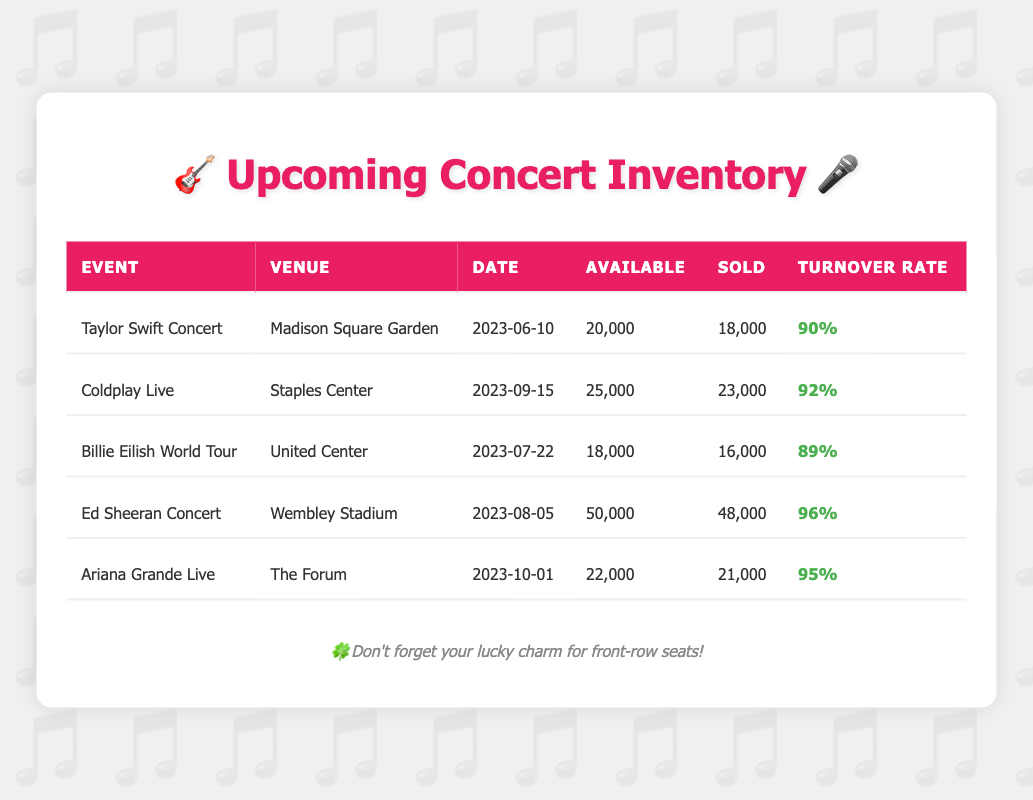What is the inventory turnover rate for the Ed Sheeran Concert? The table states that the inventory turnover rate for the Ed Sheeran Concert is displayed in the corresponding column, where it reads 96%.
Answer: 96% Which event had the highest number of tickets sold? By examining the 'Sold' column, the maximum value is 48,000 for the Ed Sheeran Concert, indicating it had the highest number of tickets sold.
Answer: Ed Sheeran Concert Is the inventory turnover rate for the Coldplay Live concert higher than 90%? The inventory turnover rate for Coldplay Live is 92%, which is indeed higher than 90%, confirming the statement is true.
Answer: Yes What is the total number of tickets sold across all events? Summing the tickets sold from each event gives 18,000 + 23,000 + 16,000 + 48,000 + 21,000 = 126,000. Therefore, the total number of tickets sold is 126,000.
Answer: 126,000 Which event had the lowest inventory turnover rate, and what was that rate? Looking at the inventory turnover rate column, the Billie Eilish World Tour shows the lowest rate at 89%, which can be confirmed by comparing all rates listed.
Answer: Billie Eilish World Tour, 89% Are there more concerts held in September than in June? The table shows one concert in June (Taylor Swift) and one in September (Coldplay Live), indicating there are not more in September.
Answer: No What is the average inventory turnover rate for all the concerts in the table? To find the average, add all turnover rates: (0.9 + 0.92 + 0.89 + 0.96 + 0.95) = 4.62. Divide by 5 (the number of events) to find the average: 4.62 / 5 = 0.924, or 92.4%.
Answer: 92.4% How many tickets are available for the Ariana Grande Live concert? The 'Available' column under Ariana Grande Live lists 22,000 tickets, indicating how many were offered for this concert.
Answer: 22,000 Is it true that the Taylor Swift Concert sold more than 85% of its tickets? The table states that Taylor Swift sold 18,000 out of 20,000 tickets, which calculates to 90%, proving the statement is true.
Answer: Yes 